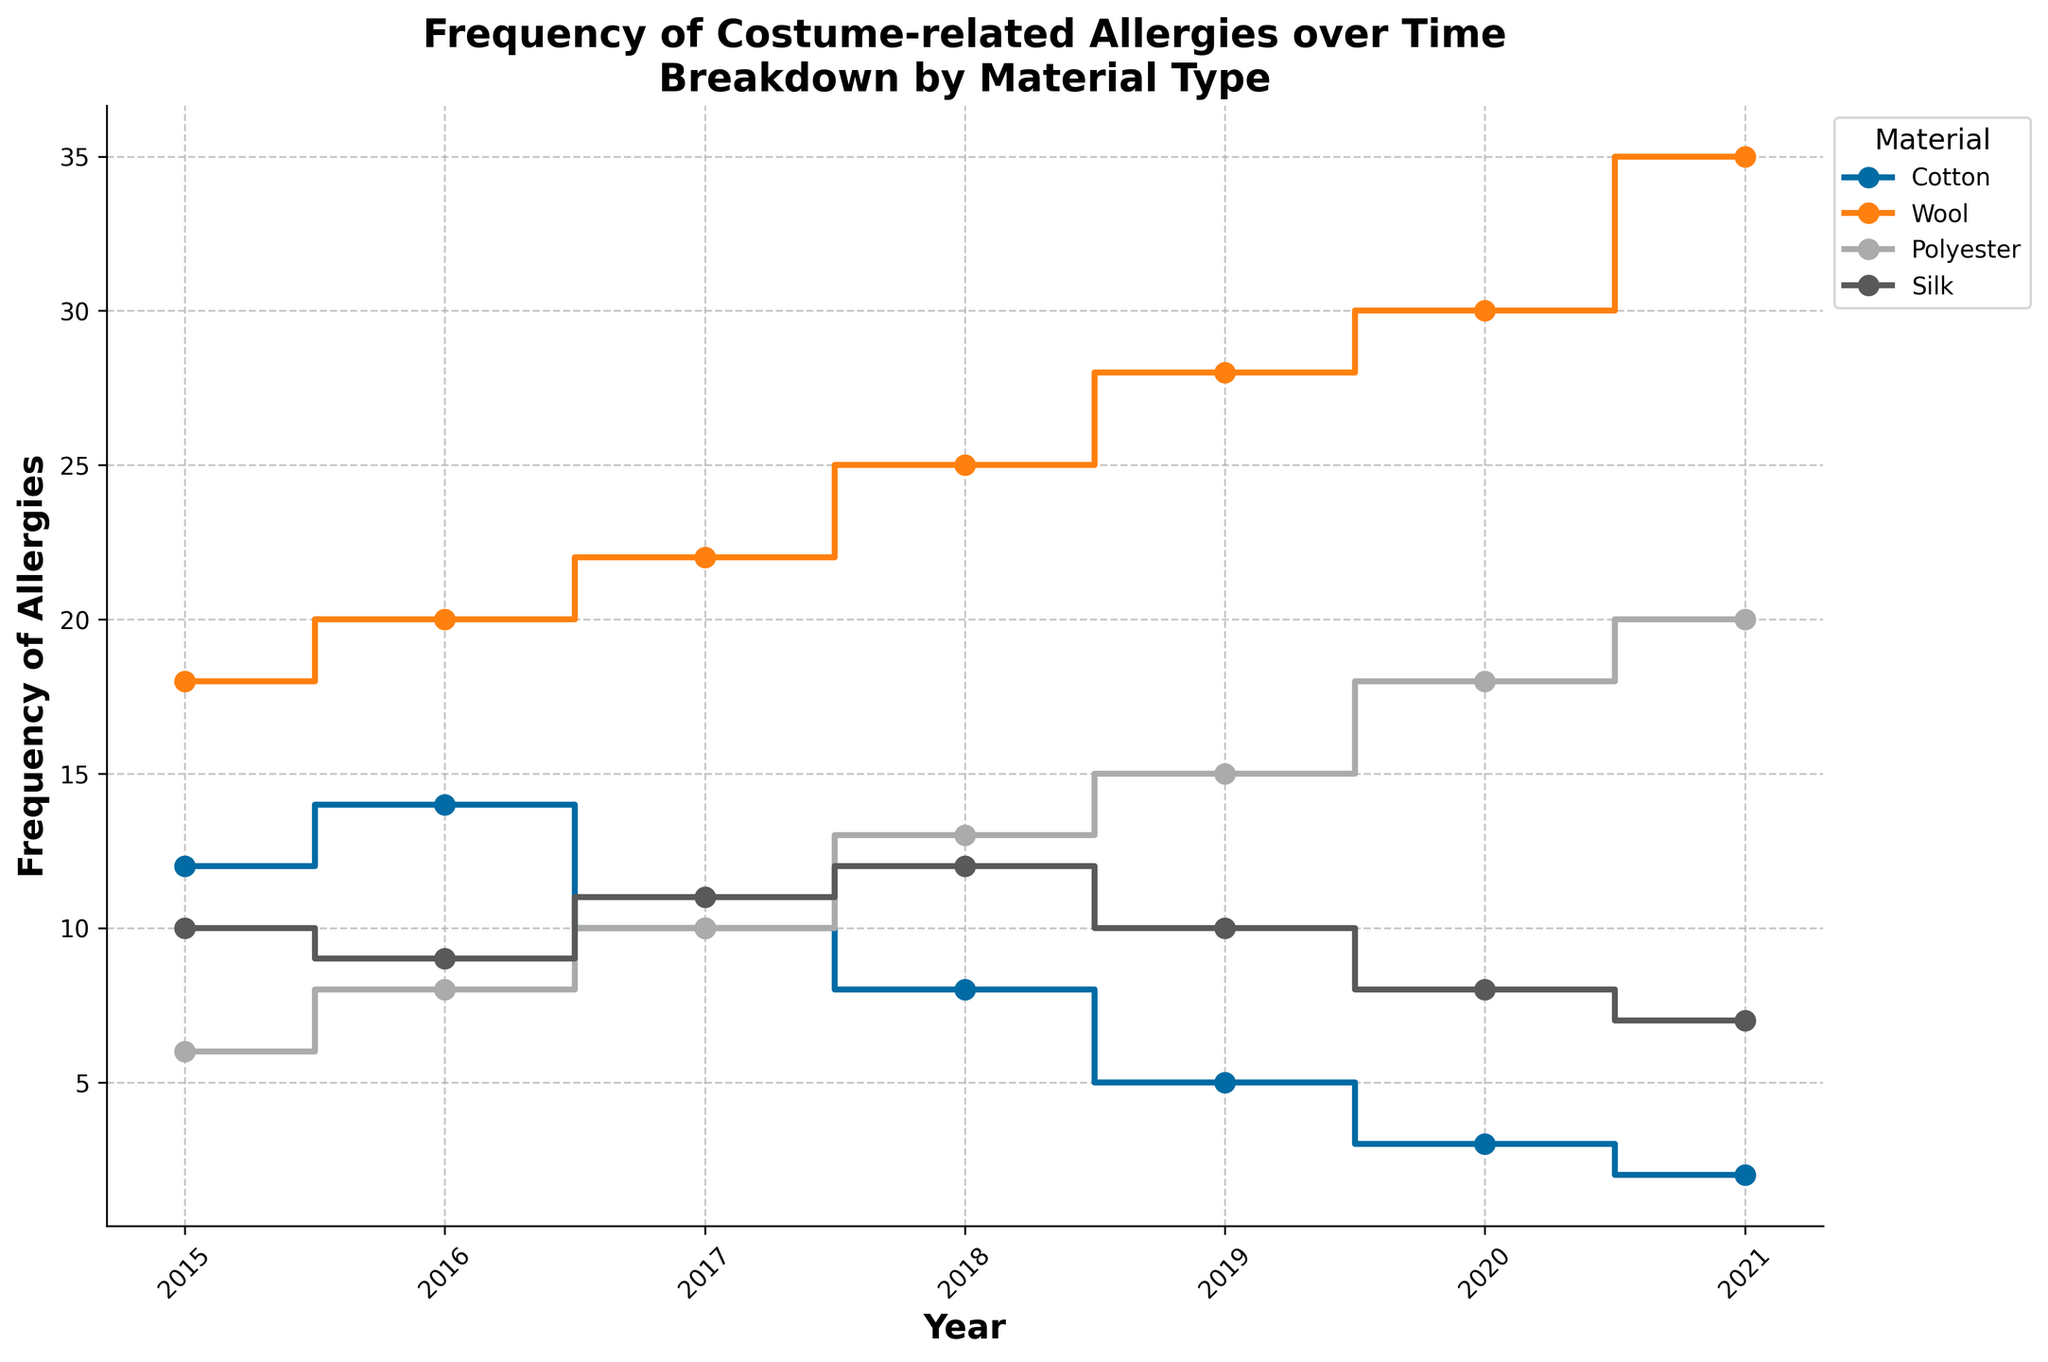What is the title of the plot? The title of the plot is the text displayed at the top of the figure for naming or describing the chart.
Answer: Frequency of Costume-related Allergies over Time with Breakdown by Material Type How many material types are considered in this plot? Determine the number of unique materials listed in the legend of the plot.
Answer: Four (Cotton, Wool, Polyester, Silk) Which material had the highest frequency of allergies in 2021? Look at the 2021 data points for all materials and identify the one with the highest frequency.
Answer: Wool How did the frequency of allergies to Polyester change from 2015 to 2021? Check the values for Polyester in 2015 and 2021, and note the increase or decrease in frequency.
Answer: Increased What is the trend for allergies related to Cotton over the years? Examine the trend line for Cotton to see if the frequency is increasing, decreasing, or stable over time.
Answer: Decreasing By how much did the frequency of allergies to Wool increase from 2015 to 2021? Calculate the difference between the frequency of Wool allergies in 2015 and in 2021. The values are 35 (2021) and 18 (2015) respectively.
Answer: 17 (35 - 18) Which material showed the most consistent trend in allergy frequency over the years? Identify the material whose trend line has the least variation up or down.
Answer: Polyester Which year saw the highest frequency of Silk-related allergies? Find the peak value on the Silk trend line and identify the corresponding year.
Answer: 2018 Comparing Cotton and Silk, which material had fewer allergies in 2019? Compare the frequency of allergies in 2019 for both Cotton and Silk.
Answer: Cotton What is the average frequency of allergies for Polyester from 2015 to 2021? Sum the frequency values for Polyester from 2015 to 2021 and divide by the number of years (7).
Answer: 12.9 [(6+8+10+13+15+18+20)/7] 